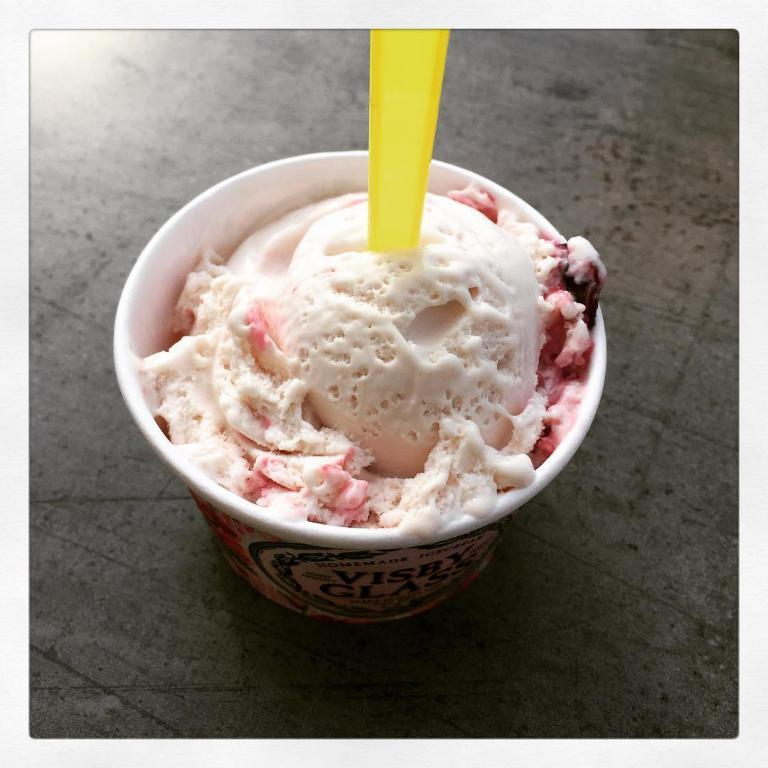What type of dessert is featured in the image? There is an ice cream in the image. How is the ice cream served? The ice cream is served in a cup. What utensil is present in the image? There is a yellow spoon in the image. What type of trail can be seen in the image? There is no trail present in the image; it features an ice cream served in a cup with a yellow spoon. 